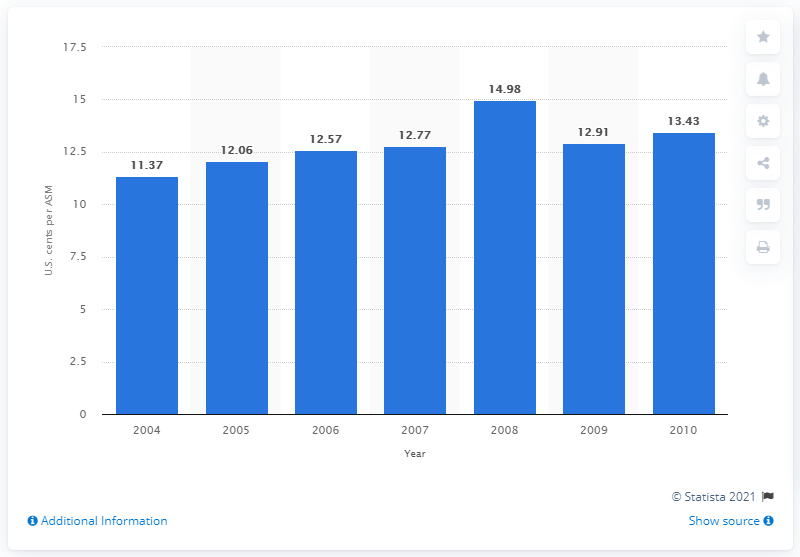Highlight a few significant elements in this photo. In 2008, the cost per available seat mile for U.S. airlines was 14.98. 